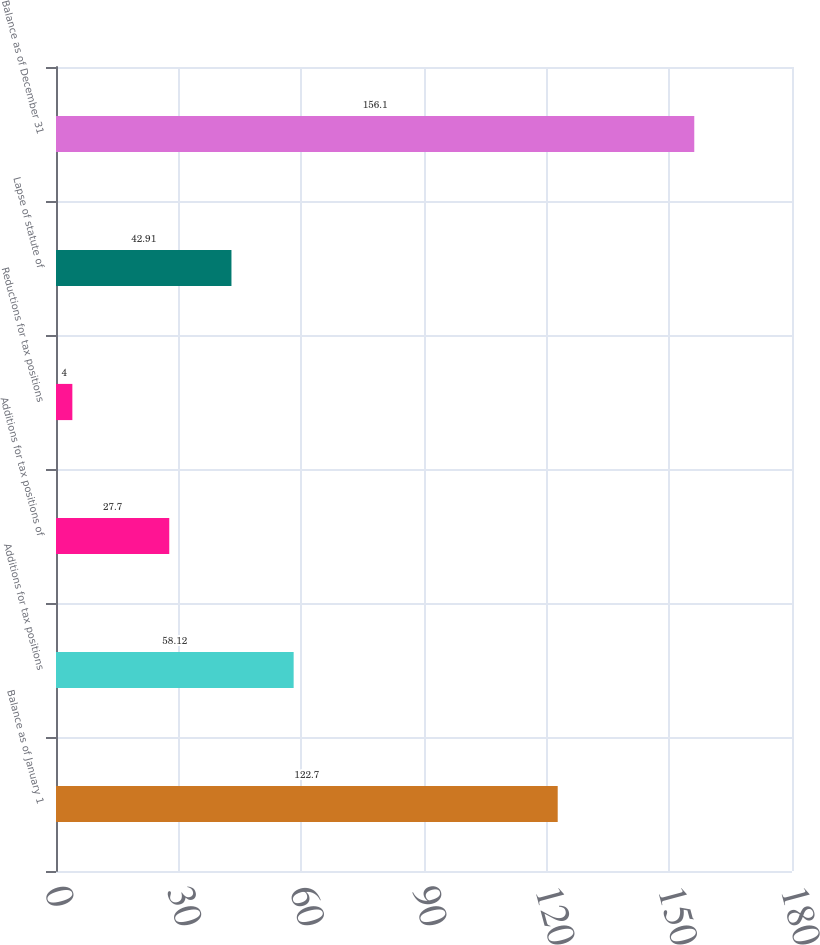<chart> <loc_0><loc_0><loc_500><loc_500><bar_chart><fcel>Balance as of January 1<fcel>Additions for tax positions<fcel>Additions for tax positions of<fcel>Reductions for tax positions<fcel>Lapse of statute of<fcel>Balance as of December 31<nl><fcel>122.7<fcel>58.12<fcel>27.7<fcel>4<fcel>42.91<fcel>156.1<nl></chart> 